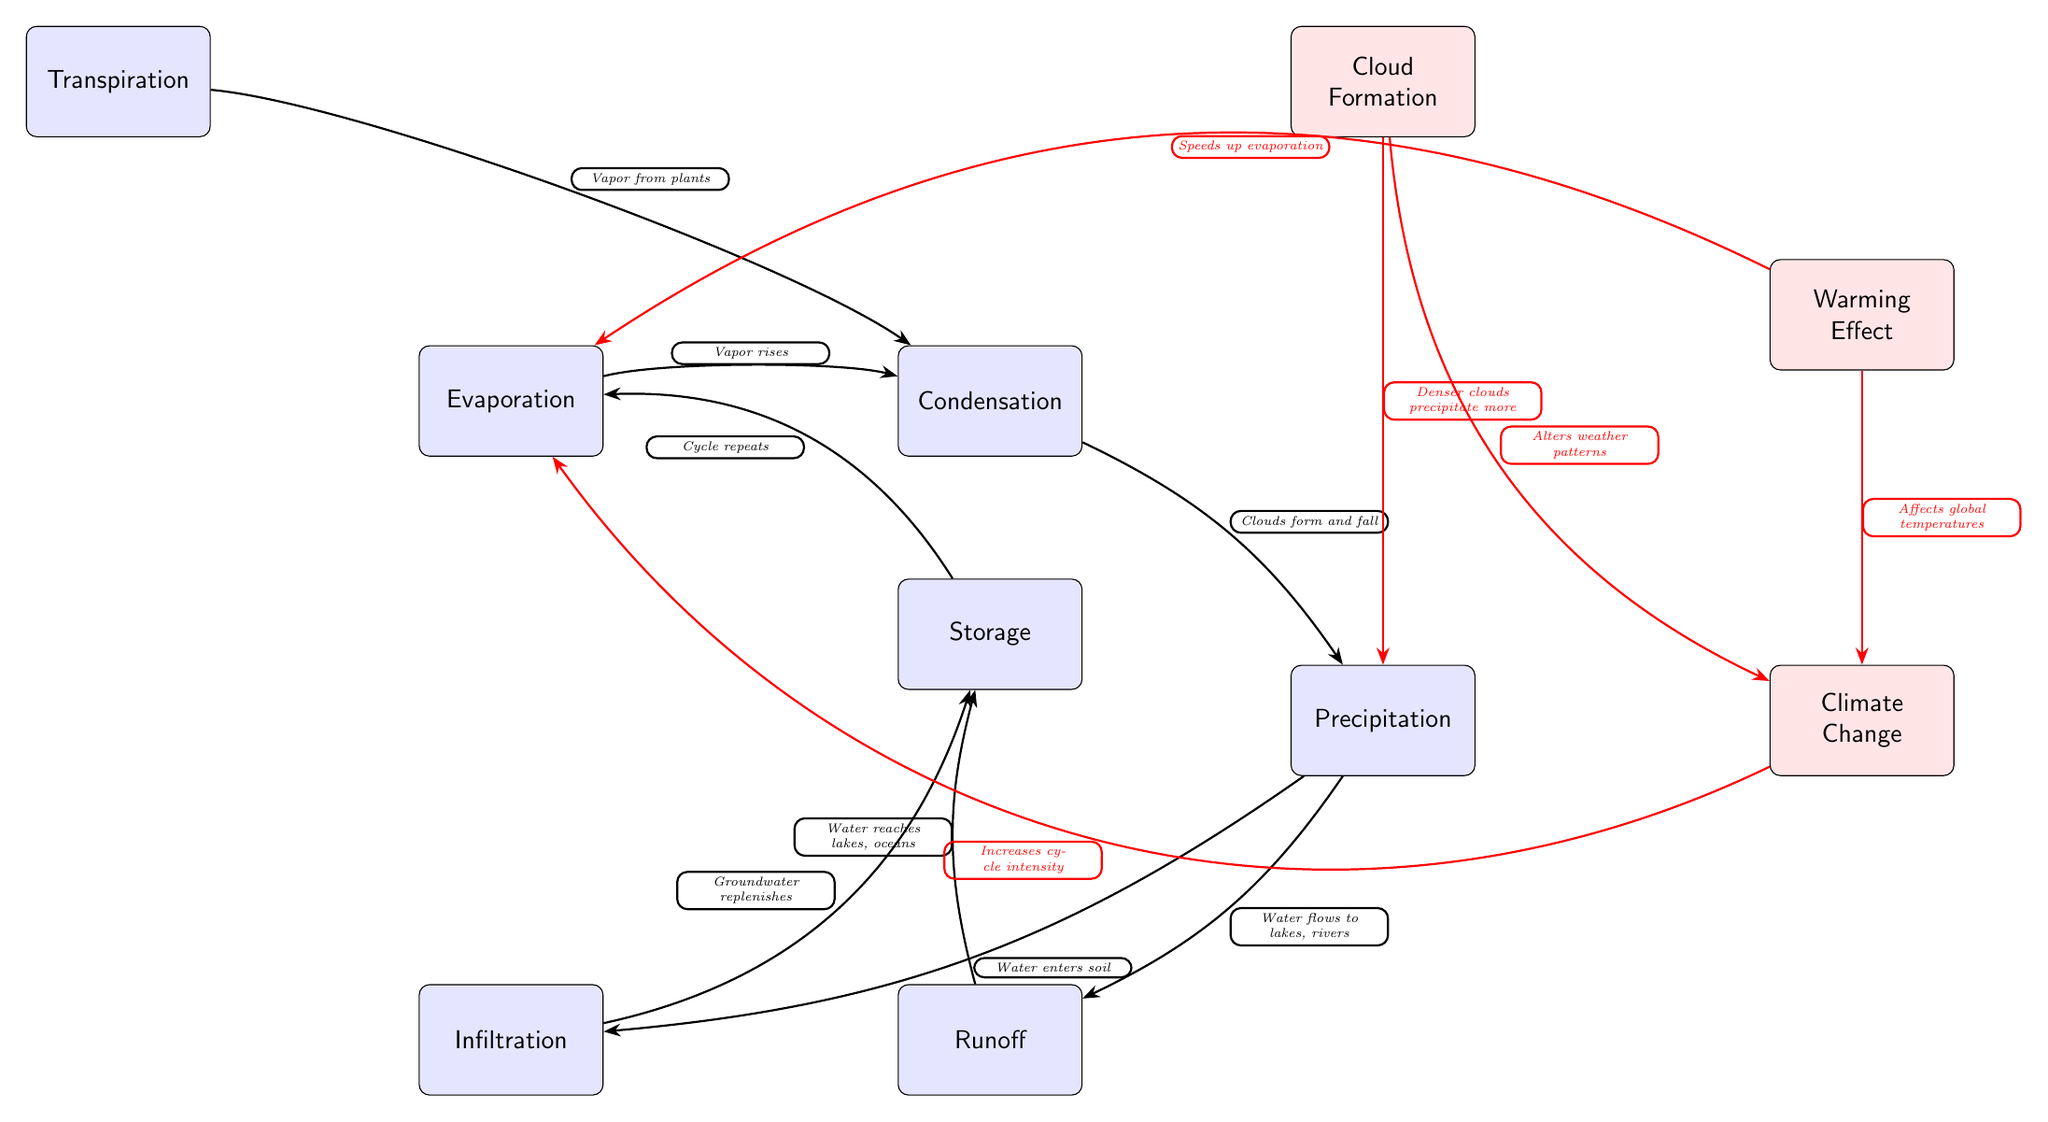What are the main processes in the water cycle? The main processes in the water cycle represented by the nodes in the diagram are evaporation, condensation, precipitation, infiltration, runoff, storage, and transpiration. These are the nodes that show the flow of water in the cycle.
Answer: Evaporation, condensation, precipitation, infiltration, runoff, storage, transpiration How many effects related to climate change are shown in the diagram? The diagram illustrates three effects related to climate change: cloud formation, climate change, and warming effect. These are represented by the effect nodes.
Answer: 3 What is the flow from condensation to precipitation? The transition from condensation to precipitation indicates that clouds form and fall, shown by the arrow connecting the two nodes with the description. This describes the process of rain resulting from condensed water vapor.
Answer: Clouds form and fall How does warming effect relate to evaporation? The warming effect is shown to speed up evaporation in the diagram, indicated by the directed arrow from the warming effect node to the evaporation node. This suggests that increased temperatures enhance the rate of evaporation occurring in the cycle.
Answer: Speeds up evaporation What happens after precipitation according to the diagram? After precipitation, two possible processes occur: water can either infiltrate into the soil or flow as runoff to lakes and rivers. Both processes are linked with arrows leading from the precipitation node.
Answer: Infiltration and runoff How does climate change impact evaporation in the water cycle? The diagram shows that climate change increases the intensity of the water cycle, which includes speeding up evaporation. This is detailed by the arrow from climate change to evaporation, indicating a direct relationship between the two aspects.
Answer: Increases cycle intensity 